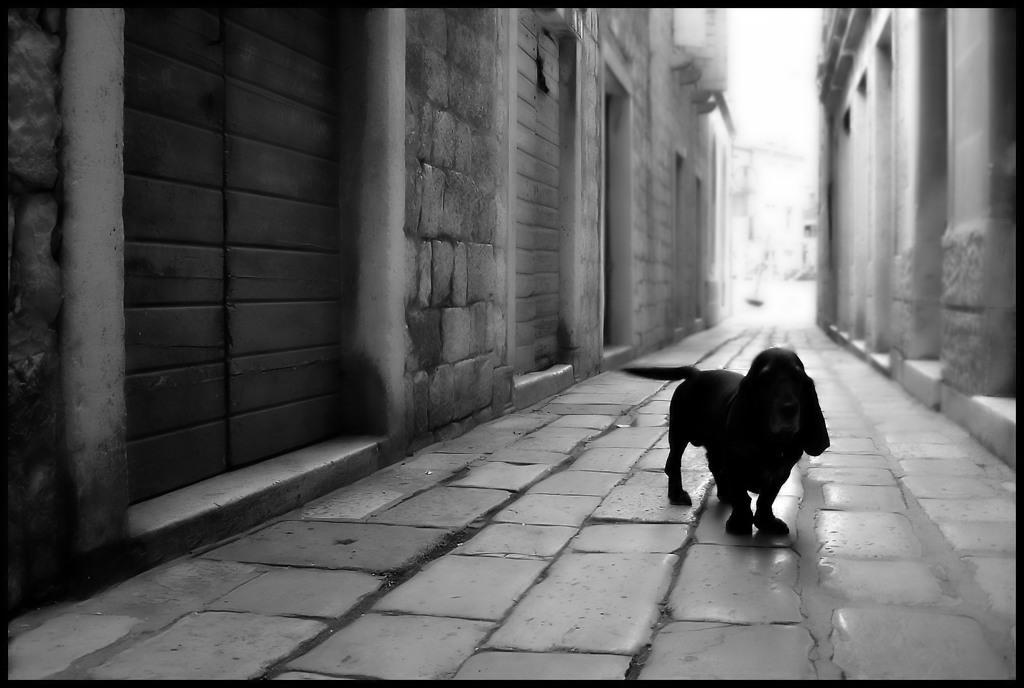Could you give a brief overview of what you see in this image? In this picture we can see a dog is standing, on the right side and left side there are buildings, it is a black and white image. 